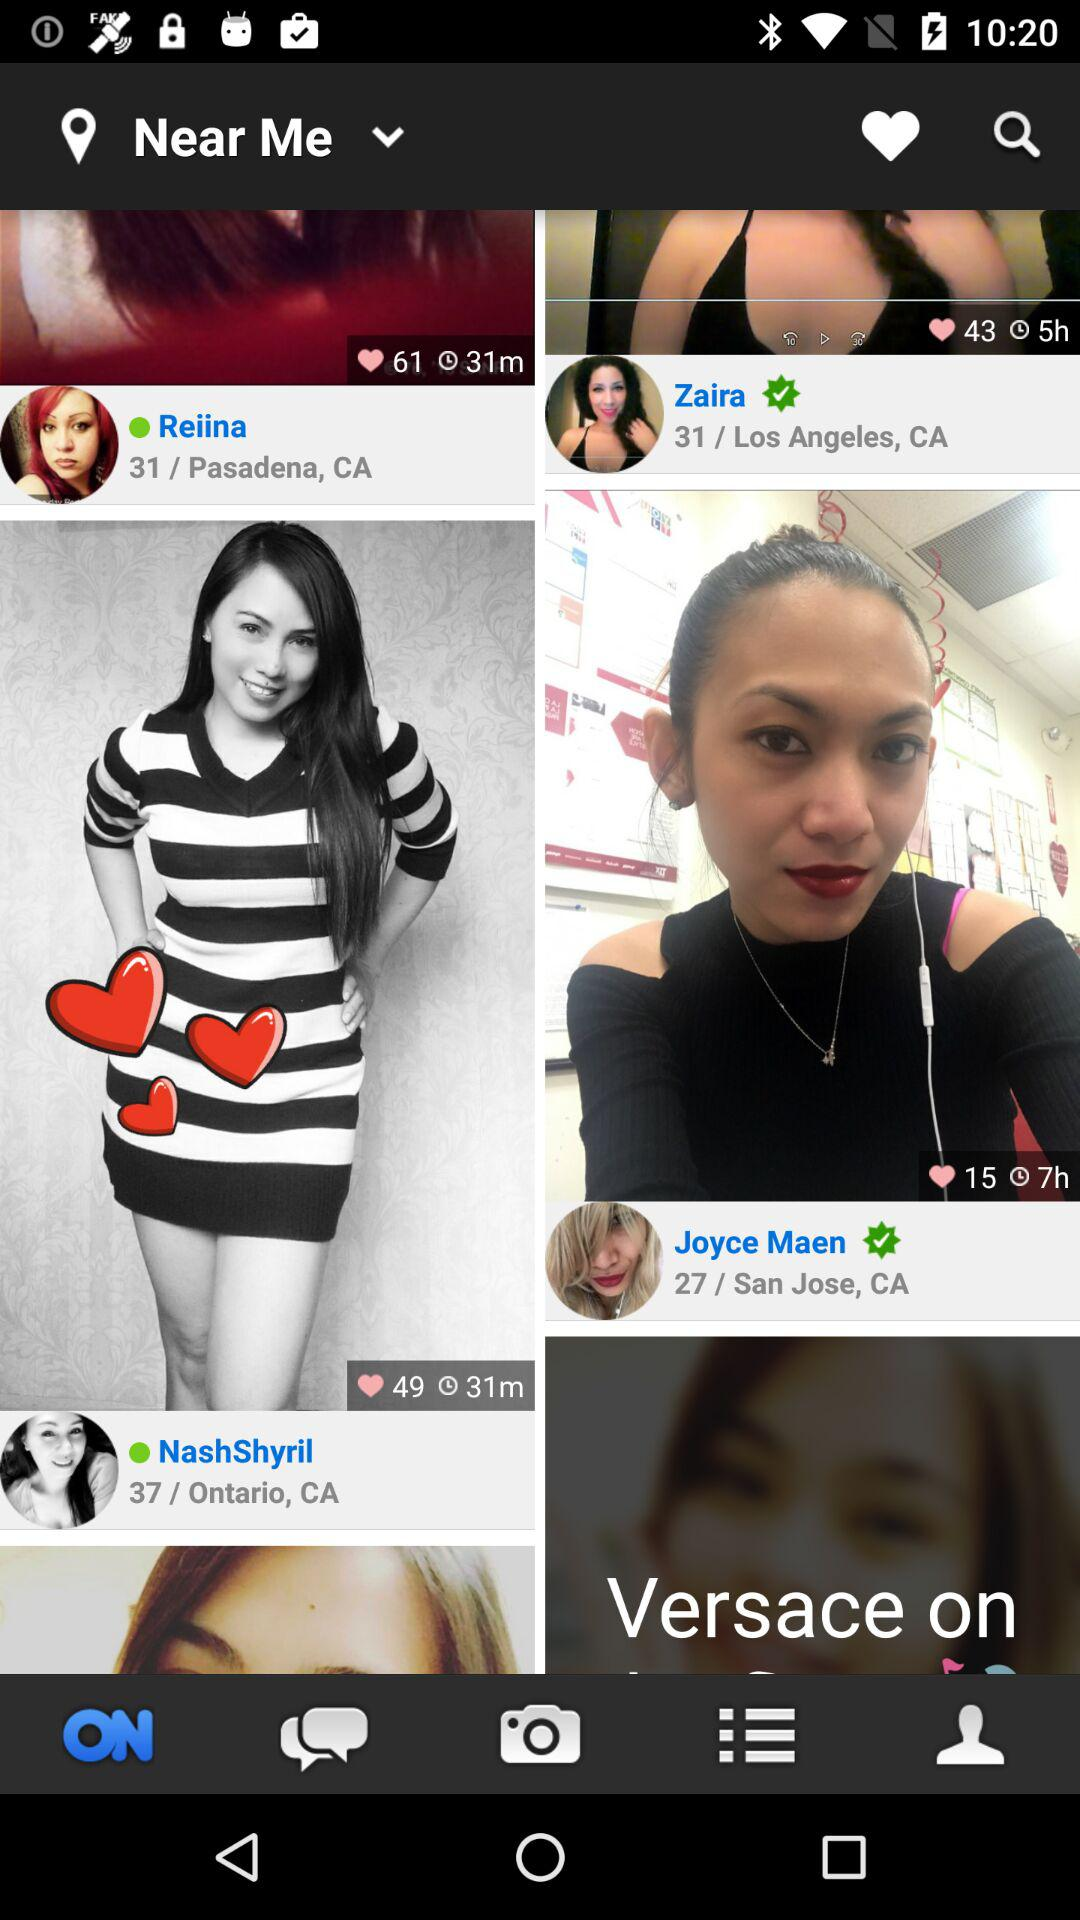Who is from Los Angeles? The one who is from Los Angeles is Zaira. 